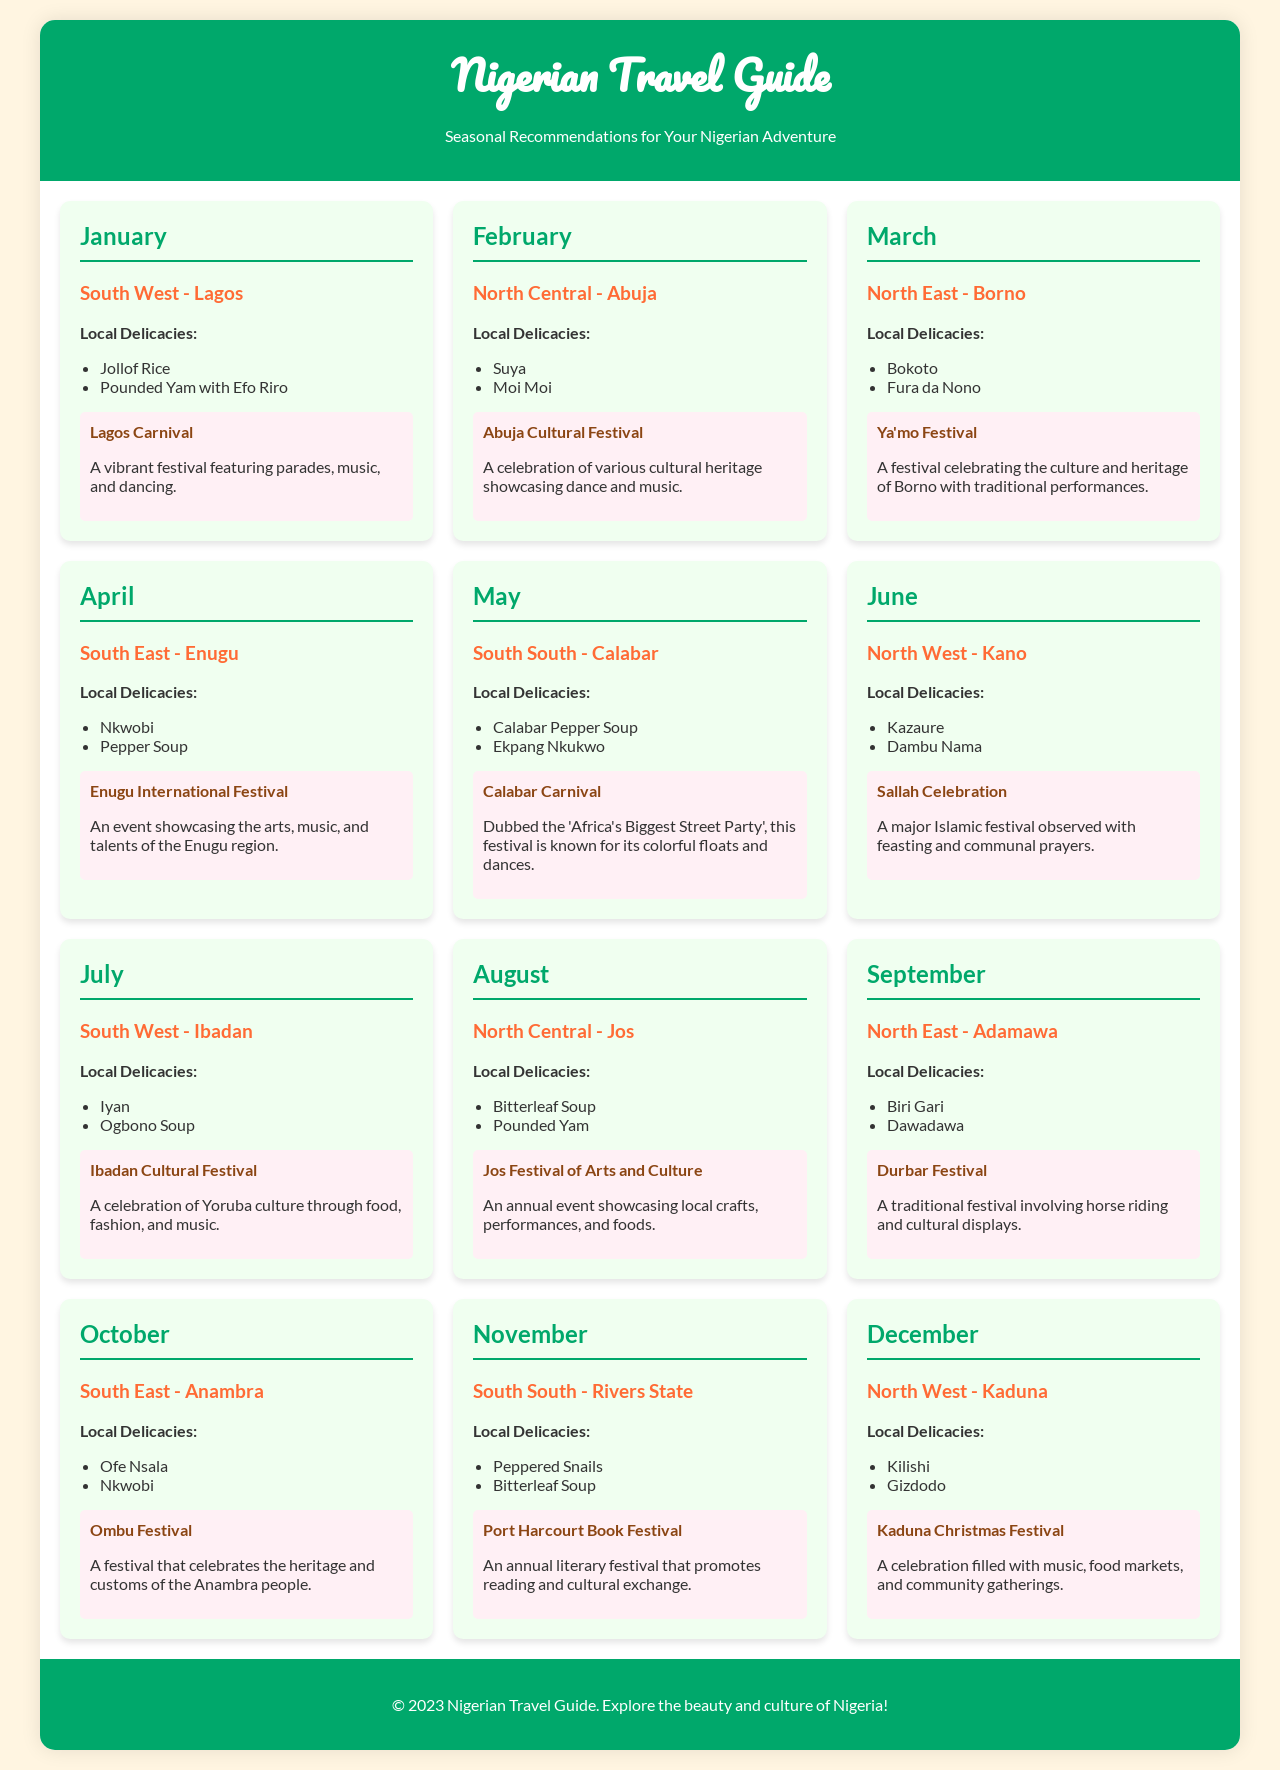What local delicacy is recommended in Lagos for January? The document lists Jollof Rice and Pounded Yam with Efo Riro as local delicacies for Lagos in January.
Answer: Jollof Rice Which festival takes place in Abuja during February? The document specifies the Abuja Cultural Festival occurring in February.
Answer: Abuja Cultural Festival What is the focus of the Jos Festival of Arts and Culture in August? The document mentions that this festival showcases local crafts, performances, and foods in Jos.
Answer: Local crafts, performances, and foods How many local delicacies are featured for Calabar in May? The document provides two local delicacies, Calabar Pepper Soup and Ekpang Nkukwo, for Calabar in May.
Answer: Two Which region hosts the Kaduna Christmas Festival in December? The document indicates that the Kaduna Christmas Festival takes place in the North West region.
Answer: North West What type of celebration occurs in Kano in June? The document notes that Sallah Celebration is a major Islamic festival observed in Kano.
Answer: Sallah Celebration What does the Ombu Festival in October celebrate? The document states that it celebrates the heritage and customs of the Anambra people.
Answer: Heritage and customs of the Anambra people What is the duration of the Calabar Carnival in May? The document does not specify the duration; it describes it as 'Africa's Biggest Street Party'.
Answer: Not specified Which local delicacy is featured in Enugu for April? The document lists Nkwobi and Pepper Soup as local delicacies for Enugu in April.
Answer: Nkwobi 